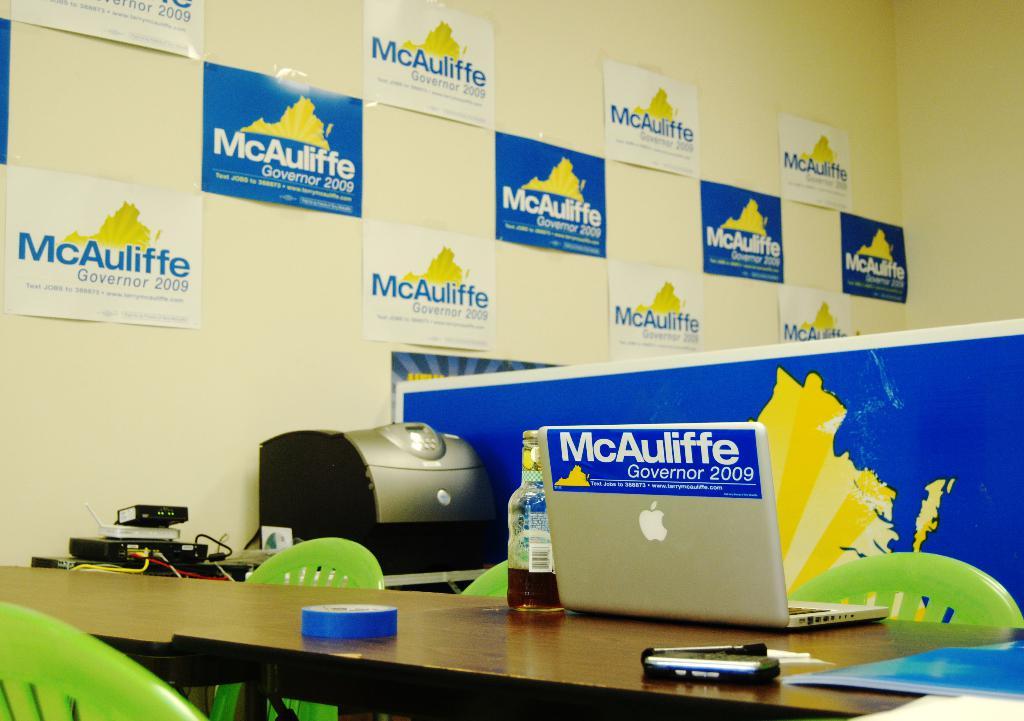What is the name of the company?
Ensure brevity in your answer.  Mcauliffe. 